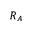Convert formula to latex. <formula><loc_0><loc_0><loc_500><loc_500>R _ { A }</formula> 